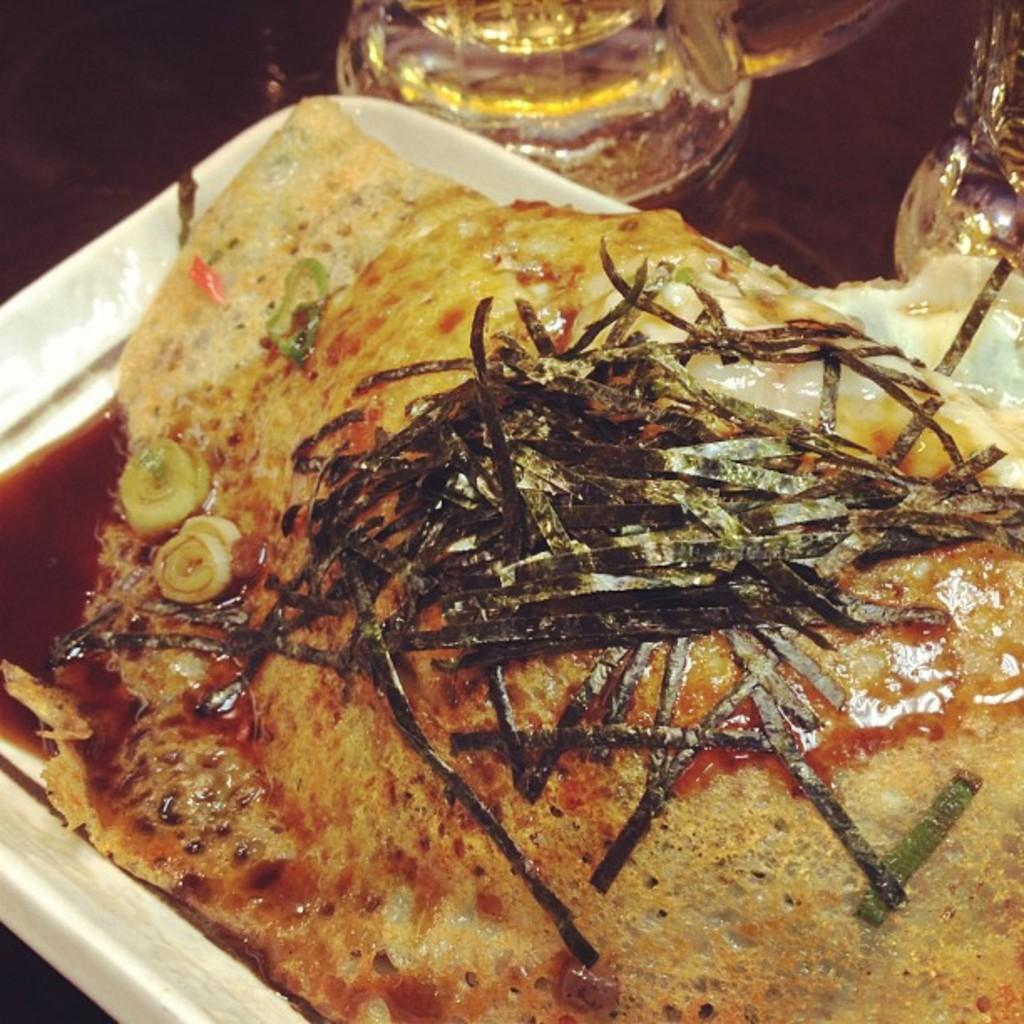What is on the tray in the image? There is a white color tray with food in the image. What else can be seen in the image besides the tray? There are glasses visible in the image. What is the color of the surface on which the tray and glasses are placed? The tray and glasses are on a brown color surface. What type of creature is sitting on the tray in the image? There is no creature present on the tray in the image; it contains food. 